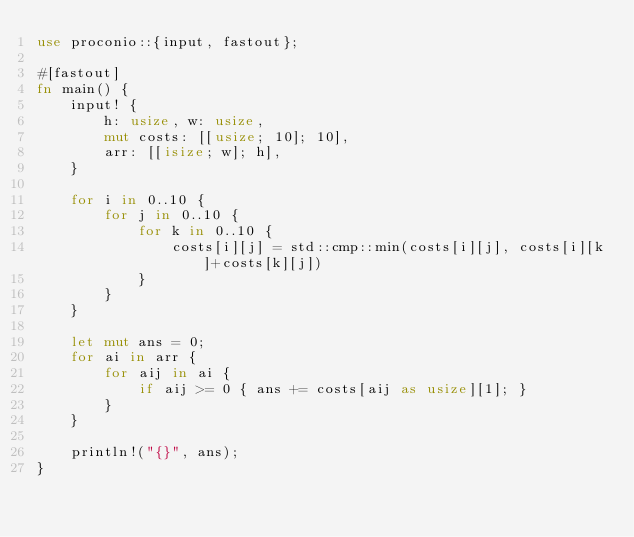Convert code to text. <code><loc_0><loc_0><loc_500><loc_500><_Rust_>use proconio::{input, fastout};

#[fastout]
fn main() {
    input! {
        h: usize, w: usize,
        mut costs: [[usize; 10]; 10],
        arr: [[isize; w]; h],
    }

    for i in 0..10 {
        for j in 0..10 {
            for k in 0..10 {
                costs[i][j] = std::cmp::min(costs[i][j], costs[i][k]+costs[k][j])
            }
        }
    }

    let mut ans = 0;
    for ai in arr {
        for aij in ai {
            if aij >= 0 { ans += costs[aij as usize][1]; }
        }
    }

    println!("{}", ans);
}
</code> 